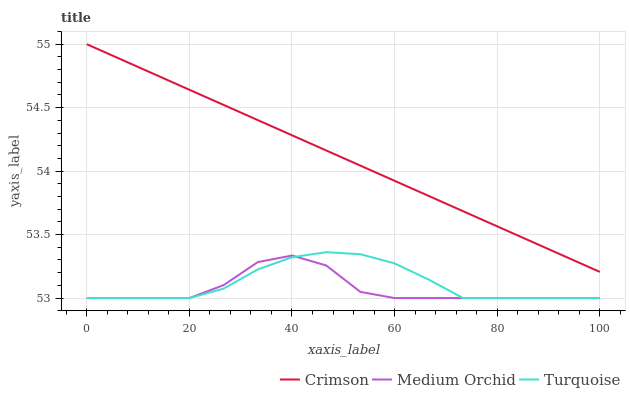Does Medium Orchid have the minimum area under the curve?
Answer yes or no. Yes. Does Crimson have the maximum area under the curve?
Answer yes or no. Yes. Does Turquoise have the minimum area under the curve?
Answer yes or no. No. Does Turquoise have the maximum area under the curve?
Answer yes or no. No. Is Crimson the smoothest?
Answer yes or no. Yes. Is Medium Orchid the roughest?
Answer yes or no. Yes. Is Turquoise the smoothest?
Answer yes or no. No. Is Turquoise the roughest?
Answer yes or no. No. Does Turquoise have the lowest value?
Answer yes or no. Yes. Does Crimson have the highest value?
Answer yes or no. Yes. Does Turquoise have the highest value?
Answer yes or no. No. Is Turquoise less than Crimson?
Answer yes or no. Yes. Is Crimson greater than Medium Orchid?
Answer yes or no. Yes. Does Turquoise intersect Medium Orchid?
Answer yes or no. Yes. Is Turquoise less than Medium Orchid?
Answer yes or no. No. Is Turquoise greater than Medium Orchid?
Answer yes or no. No. Does Turquoise intersect Crimson?
Answer yes or no. No. 